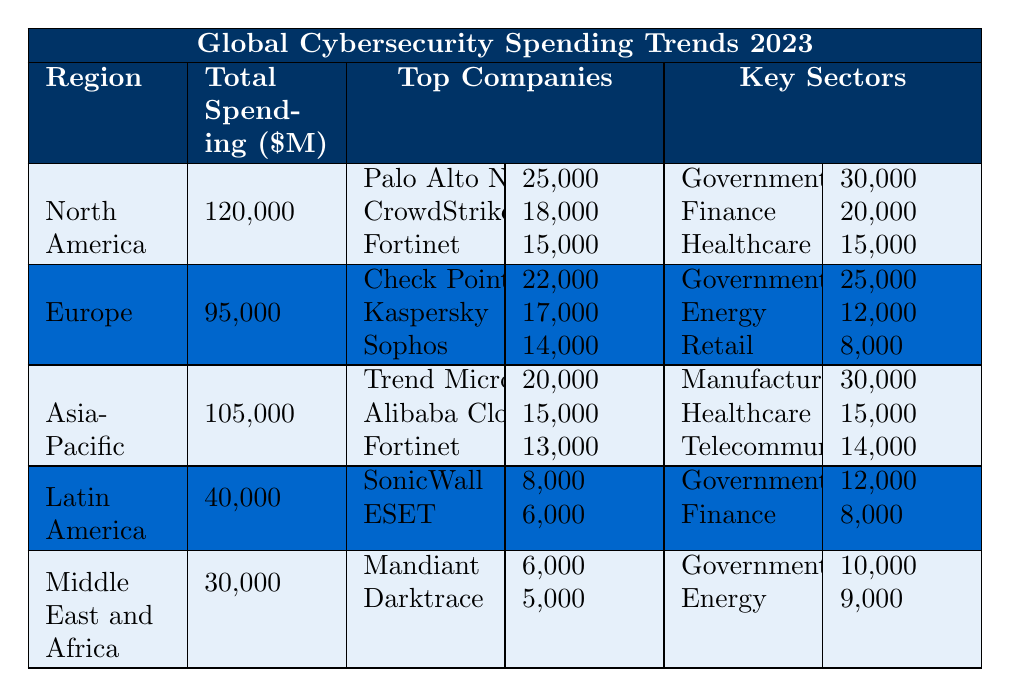What is the total spending on cybersecurity in North America? The table states that the total spending in North America is listed under the "Total Spending" column, which shows 120,000 million dollars.
Answer: 120,000 million Which region has the highest total cybersecurity spending? By comparing the "Total Spending" values for all regions, North America has the highest at 120,000 million, followed by Asia-Pacific at 105,000 million.
Answer: North America How much did the top company in Europe spend on cybersecurity? The table indicates that the top company in Europe, Check Point Software, spent 22,000 million.
Answer: 22,000 million What is the combined spending of the top two companies in Asia-Pacific? The top two companies in Asia-Pacific are Trend Micro, which spent 20,000 million, and Alibaba Cloud Security, which spent 15,000 million. Adding these amounts together gives 20,000 + 15,000 = 35,000 million.
Answer: 35,000 million Which sector received the highest cybersecurity spending in Latin America? The "Key Sectors" row shows that the Government sector received the highest spending of 12,000 million, compared to 8,000 million for the Finance sector.
Answer: Government Does Europe have a higher total spending than Latin America? By comparing the "Total Spending" for both regions, Europe has 95,000 million while Latin America has 40,000 million, which means Europe spends significantly more.
Answer: Yes What is the total amount spent on cybersecurity by the top companies in North America? Adding the top companies' spending: Palo Alto Networks (25,000), CrowdStrike (18,000), and Fortinet (15,000) gives 25,000 + 18,000 + 15,000 = 58,000 million.
Answer: 58,000 million Which region spends the least on cybersecurity? Looking at the "Total Spending" column, the Middle East and Africa has the least at 30,000 million, followed by Latin America at 40,000 million.
Answer: Middle East and Africa What percentage of the total cybersecurity spending in Asia-Pacific was spent on the Manufacturing sector? The total spending in Asia-Pacific is 105,000 million, and the Manufacturing sector received 30,000 million. Thus, (30,000 / 105,000) * 100 ≈ 28.57%.
Answer: 28.57% If we combine the spending of the Government sector across all regions, what is the total? Summing the Government sector spending from all regions: North America (30,000), Europe (25,000), Asia-Pacific (30,000), Latin America (12,000), and Middle East and Africa (10,000) gives 30,000 + 25,000 + 30,000 + 12,000 + 10,000 = 117,000 million.
Answer: 117,000 million 